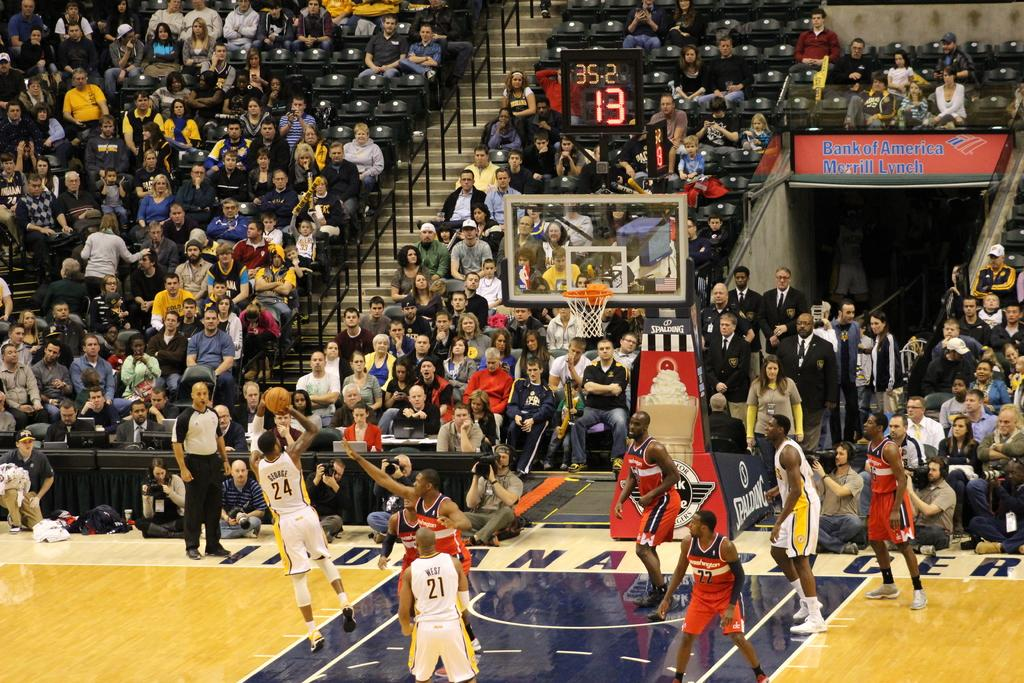<image>
Give a short and clear explanation of the subsequent image. A basketball player shoots a fade away with 13 seconds left on the shot clock and 35 seconds left in the half. 